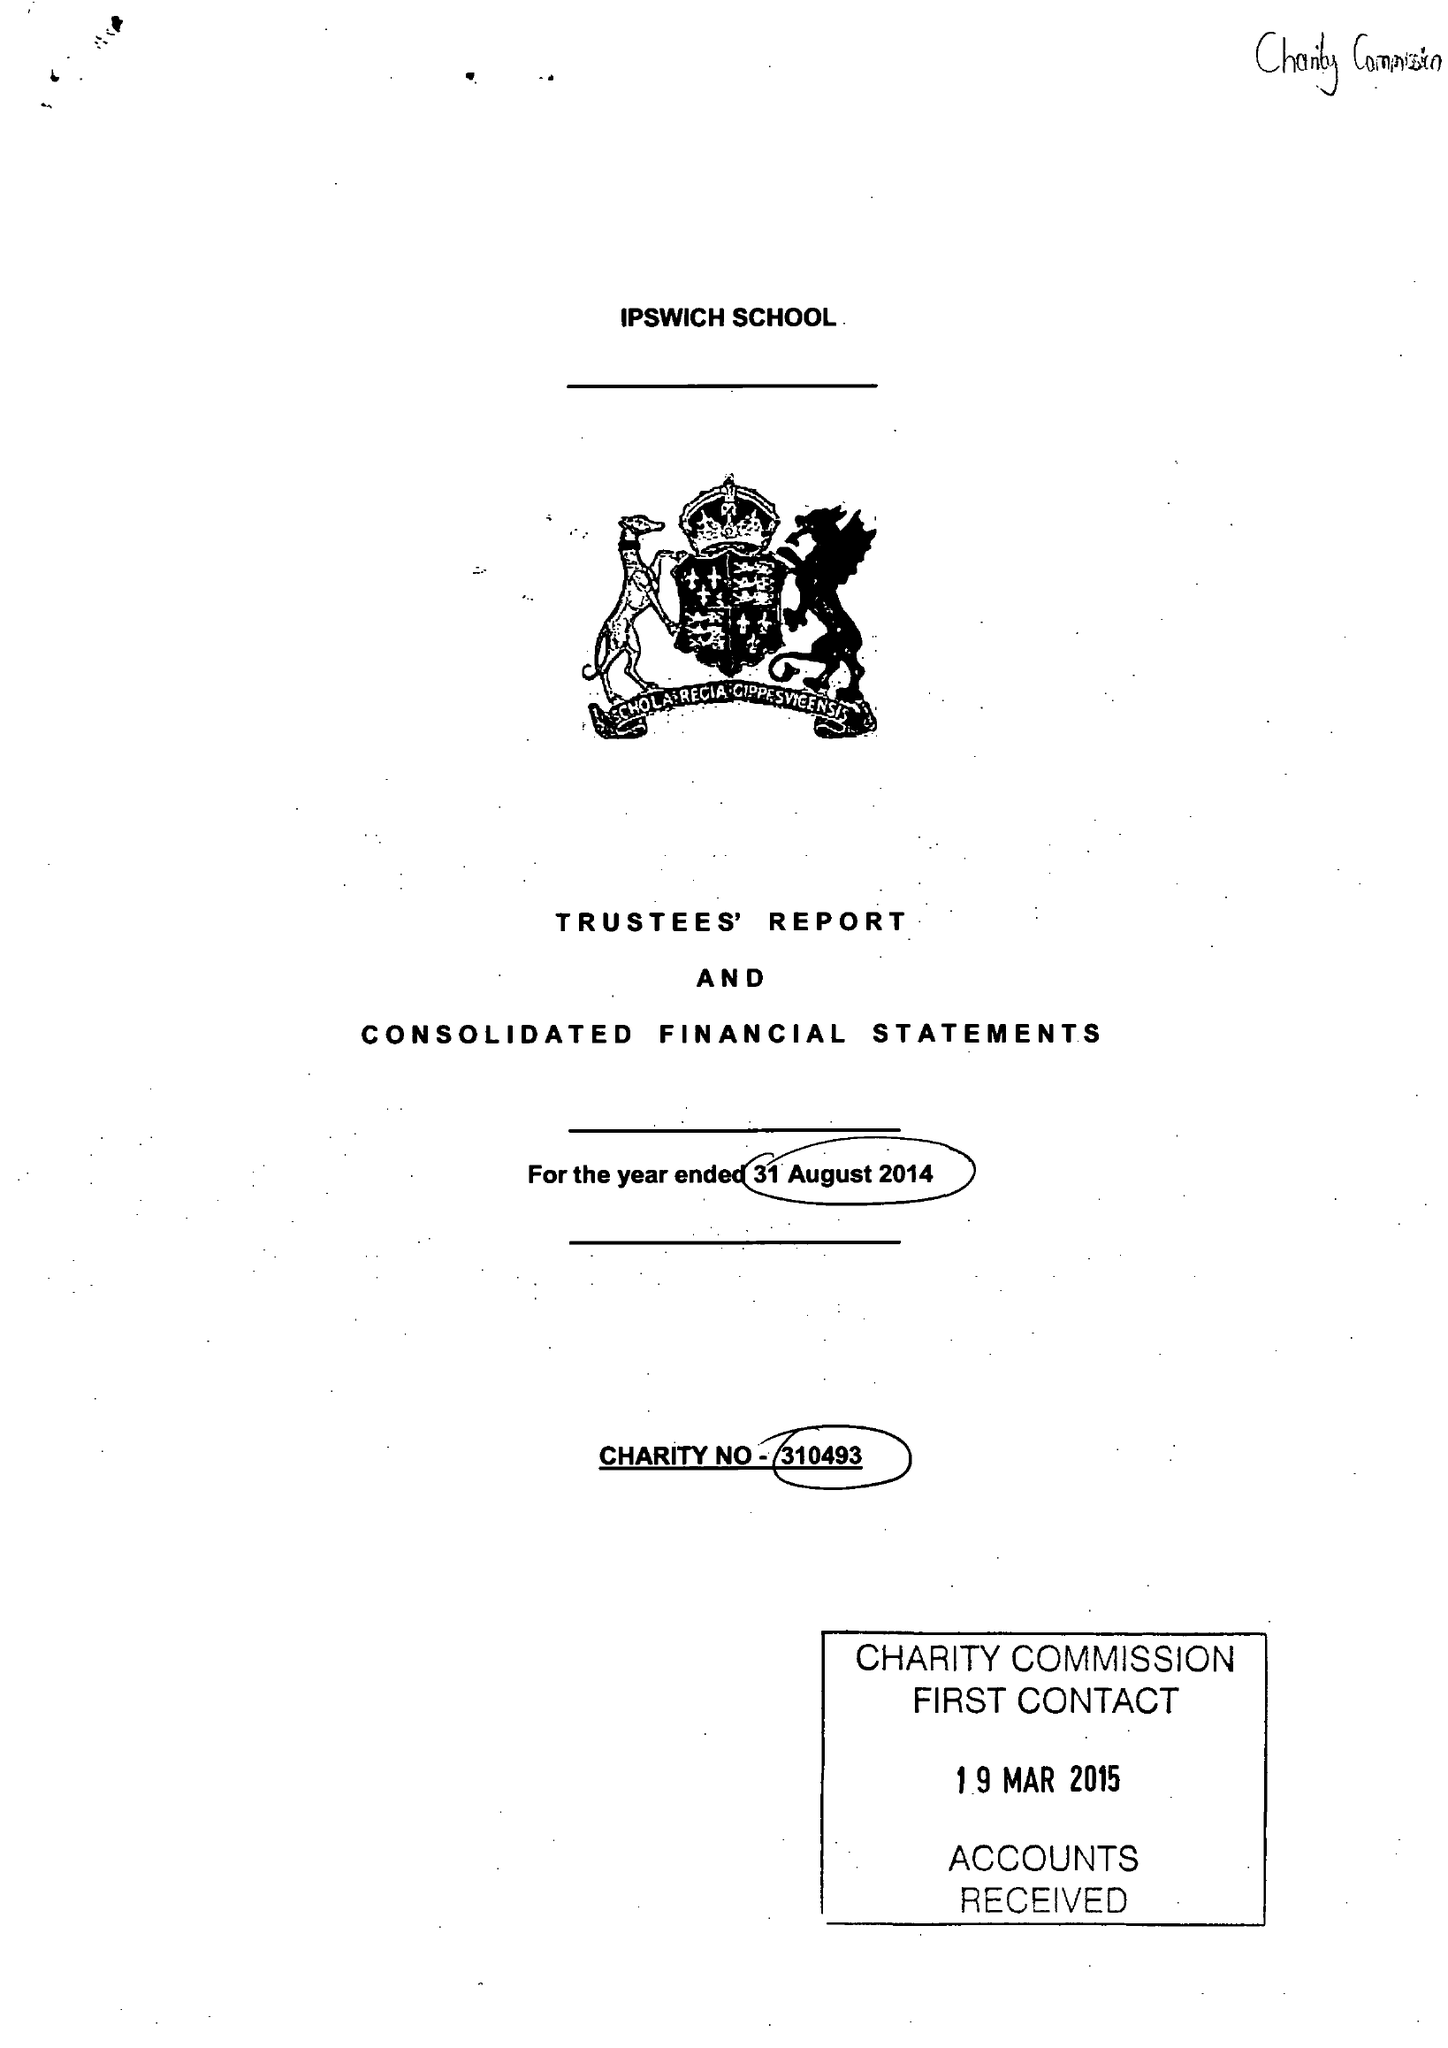What is the value for the address__post_town?
Answer the question using a single word or phrase. IPSWICH 